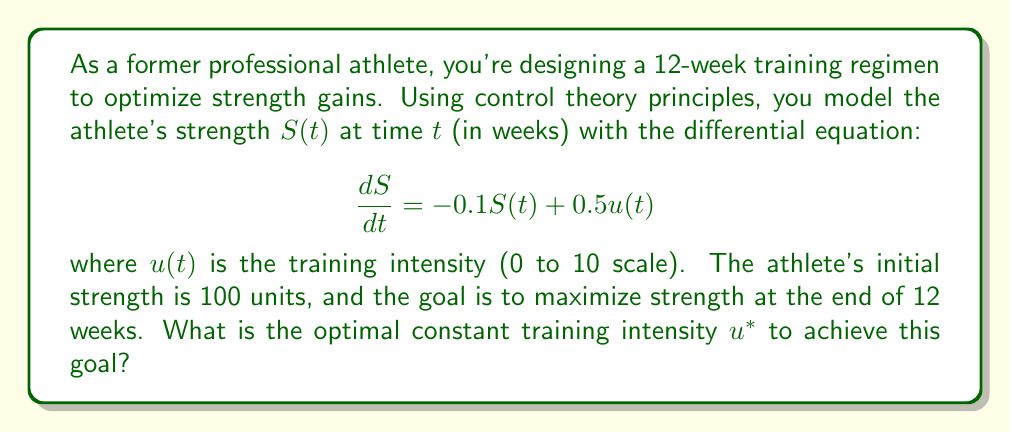Give your solution to this math problem. To solve this problem, we'll use the principles of optimal control theory:

1) First, we need to solve the differential equation for $S(t)$ given a constant $u(t) = u^*$:

   $$\frac{dS}{dt} + 0.1S = 0.5u^*$$

2) This is a first-order linear differential equation. The general solution is:

   $$S(t) = Ce^{-0.1t} + 5u^*$$

   where $C$ is a constant determined by the initial condition.

3) Given the initial condition $S(0) = 100$, we can find $C$:

   $$100 = C + 5u^*$$
   $$C = 100 - 5u^*$$

4) Therefore, the complete solution is:

   $$S(t) = (100 - 5u^*)e^{-0.1t} + 5u^*$$

5) We want to maximize $S(12)$, so let's evaluate this at $t=12$:

   $$S(12) = (100 - 5u^*)e^{-1.2} + 5u^*$$

6) To find the maximum, we differentiate with respect to $u^*$ and set to zero:

   $$\frac{dS(12)}{du^*} = -5e^{-1.2} + 5 = 0$$

7) Solving this equation:

   $$5e^{-1.2} = 5$$
   $$e^{-1.2} = 1$$

   This is always true, meaning $S(12)$ increases linearly with $u^*$.

8) Since $u^*$ is bounded between 0 and 10, the maximum occurs at the upper bound, $u^* = 10$.
Answer: The optimal constant training intensity is $u^* = 10$. 